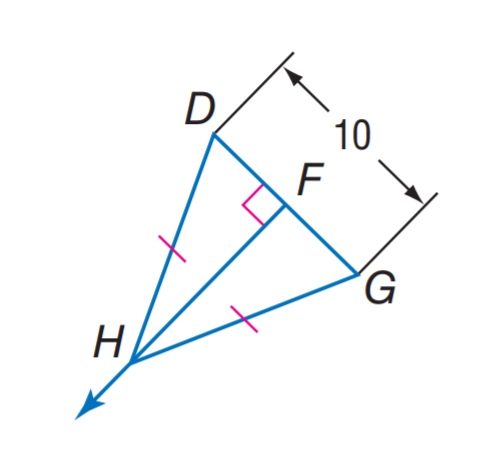Answer the mathemtical geometry problem and directly provide the correct option letter.
Question: Find D F.
Choices: A: 5 B: 10 C: 15 D: 20 A 